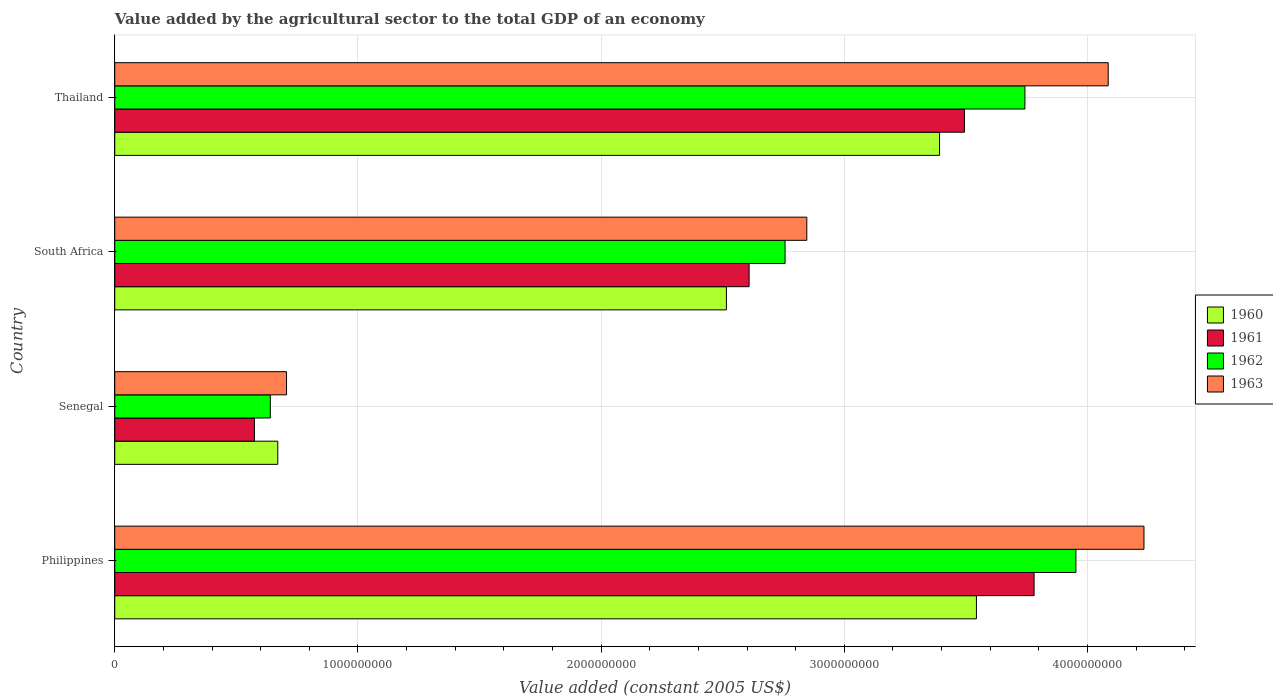How many different coloured bars are there?
Ensure brevity in your answer.  4. Are the number of bars per tick equal to the number of legend labels?
Offer a very short reply. Yes. Are the number of bars on each tick of the Y-axis equal?
Make the answer very short. Yes. How many bars are there on the 3rd tick from the bottom?
Offer a terse response. 4. In how many cases, is the number of bars for a given country not equal to the number of legend labels?
Give a very brief answer. 0. What is the value added by the agricultural sector in 1963 in Philippines?
Your answer should be very brief. 4.23e+09. Across all countries, what is the maximum value added by the agricultural sector in 1962?
Give a very brief answer. 3.95e+09. Across all countries, what is the minimum value added by the agricultural sector in 1963?
Provide a short and direct response. 7.06e+08. In which country was the value added by the agricultural sector in 1960 maximum?
Give a very brief answer. Philippines. In which country was the value added by the agricultural sector in 1963 minimum?
Your response must be concise. Senegal. What is the total value added by the agricultural sector in 1963 in the graph?
Keep it short and to the point. 1.19e+1. What is the difference between the value added by the agricultural sector in 1961 in Senegal and that in Thailand?
Ensure brevity in your answer.  -2.92e+09. What is the difference between the value added by the agricultural sector in 1963 in Thailand and the value added by the agricultural sector in 1961 in South Africa?
Ensure brevity in your answer.  1.48e+09. What is the average value added by the agricultural sector in 1962 per country?
Your answer should be compact. 2.77e+09. What is the difference between the value added by the agricultural sector in 1963 and value added by the agricultural sector in 1961 in Thailand?
Your answer should be very brief. 5.91e+08. In how many countries, is the value added by the agricultural sector in 1962 greater than 600000000 US$?
Your answer should be compact. 4. What is the ratio of the value added by the agricultural sector in 1961 in Philippines to that in Senegal?
Offer a terse response. 6.58. Is the value added by the agricultural sector in 1962 in Philippines less than that in Thailand?
Your answer should be very brief. No. Is the difference between the value added by the agricultural sector in 1963 in Senegal and South Africa greater than the difference between the value added by the agricultural sector in 1961 in Senegal and South Africa?
Provide a short and direct response. No. What is the difference between the highest and the second highest value added by the agricultural sector in 1962?
Offer a very short reply. 2.10e+08. What is the difference between the highest and the lowest value added by the agricultural sector in 1962?
Offer a terse response. 3.31e+09. In how many countries, is the value added by the agricultural sector in 1961 greater than the average value added by the agricultural sector in 1961 taken over all countries?
Your answer should be compact. 2. Is it the case that in every country, the sum of the value added by the agricultural sector in 1961 and value added by the agricultural sector in 1962 is greater than the sum of value added by the agricultural sector in 1960 and value added by the agricultural sector in 1963?
Your response must be concise. No. What does the 3rd bar from the top in South Africa represents?
Provide a succinct answer. 1961. Is it the case that in every country, the sum of the value added by the agricultural sector in 1960 and value added by the agricultural sector in 1961 is greater than the value added by the agricultural sector in 1963?
Offer a terse response. Yes. Are all the bars in the graph horizontal?
Ensure brevity in your answer.  Yes. Does the graph contain grids?
Your answer should be compact. Yes. Where does the legend appear in the graph?
Give a very brief answer. Center right. What is the title of the graph?
Provide a succinct answer. Value added by the agricultural sector to the total GDP of an economy. Does "1995" appear as one of the legend labels in the graph?
Provide a succinct answer. No. What is the label or title of the X-axis?
Your response must be concise. Value added (constant 2005 US$). What is the Value added (constant 2005 US$) in 1960 in Philippines?
Offer a very short reply. 3.54e+09. What is the Value added (constant 2005 US$) in 1961 in Philippines?
Your answer should be compact. 3.78e+09. What is the Value added (constant 2005 US$) in 1962 in Philippines?
Keep it short and to the point. 3.95e+09. What is the Value added (constant 2005 US$) of 1963 in Philippines?
Keep it short and to the point. 4.23e+09. What is the Value added (constant 2005 US$) in 1960 in Senegal?
Make the answer very short. 6.70e+08. What is the Value added (constant 2005 US$) in 1961 in Senegal?
Ensure brevity in your answer.  5.74e+08. What is the Value added (constant 2005 US$) of 1962 in Senegal?
Ensure brevity in your answer.  6.40e+08. What is the Value added (constant 2005 US$) in 1963 in Senegal?
Provide a succinct answer. 7.06e+08. What is the Value added (constant 2005 US$) of 1960 in South Africa?
Give a very brief answer. 2.52e+09. What is the Value added (constant 2005 US$) in 1961 in South Africa?
Your answer should be very brief. 2.61e+09. What is the Value added (constant 2005 US$) in 1962 in South Africa?
Offer a terse response. 2.76e+09. What is the Value added (constant 2005 US$) of 1963 in South Africa?
Offer a very short reply. 2.85e+09. What is the Value added (constant 2005 US$) of 1960 in Thailand?
Make the answer very short. 3.39e+09. What is the Value added (constant 2005 US$) of 1961 in Thailand?
Offer a terse response. 3.49e+09. What is the Value added (constant 2005 US$) of 1962 in Thailand?
Your answer should be compact. 3.74e+09. What is the Value added (constant 2005 US$) of 1963 in Thailand?
Your response must be concise. 4.09e+09. Across all countries, what is the maximum Value added (constant 2005 US$) of 1960?
Offer a terse response. 3.54e+09. Across all countries, what is the maximum Value added (constant 2005 US$) of 1961?
Give a very brief answer. 3.78e+09. Across all countries, what is the maximum Value added (constant 2005 US$) in 1962?
Provide a succinct answer. 3.95e+09. Across all countries, what is the maximum Value added (constant 2005 US$) in 1963?
Your response must be concise. 4.23e+09. Across all countries, what is the minimum Value added (constant 2005 US$) of 1960?
Offer a terse response. 6.70e+08. Across all countries, what is the minimum Value added (constant 2005 US$) in 1961?
Offer a very short reply. 5.74e+08. Across all countries, what is the minimum Value added (constant 2005 US$) of 1962?
Offer a very short reply. 6.40e+08. Across all countries, what is the minimum Value added (constant 2005 US$) of 1963?
Provide a succinct answer. 7.06e+08. What is the total Value added (constant 2005 US$) in 1960 in the graph?
Your response must be concise. 1.01e+1. What is the total Value added (constant 2005 US$) in 1961 in the graph?
Provide a succinct answer. 1.05e+1. What is the total Value added (constant 2005 US$) of 1962 in the graph?
Offer a very short reply. 1.11e+1. What is the total Value added (constant 2005 US$) of 1963 in the graph?
Provide a short and direct response. 1.19e+1. What is the difference between the Value added (constant 2005 US$) of 1960 in Philippines and that in Senegal?
Your response must be concise. 2.87e+09. What is the difference between the Value added (constant 2005 US$) of 1961 in Philippines and that in Senegal?
Ensure brevity in your answer.  3.21e+09. What is the difference between the Value added (constant 2005 US$) of 1962 in Philippines and that in Senegal?
Provide a succinct answer. 3.31e+09. What is the difference between the Value added (constant 2005 US$) of 1963 in Philippines and that in Senegal?
Keep it short and to the point. 3.53e+09. What is the difference between the Value added (constant 2005 US$) of 1960 in Philippines and that in South Africa?
Make the answer very short. 1.03e+09. What is the difference between the Value added (constant 2005 US$) in 1961 in Philippines and that in South Africa?
Offer a terse response. 1.17e+09. What is the difference between the Value added (constant 2005 US$) in 1962 in Philippines and that in South Africa?
Ensure brevity in your answer.  1.20e+09. What is the difference between the Value added (constant 2005 US$) of 1963 in Philippines and that in South Africa?
Your response must be concise. 1.39e+09. What is the difference between the Value added (constant 2005 US$) of 1960 in Philippines and that in Thailand?
Provide a short and direct response. 1.52e+08. What is the difference between the Value added (constant 2005 US$) of 1961 in Philippines and that in Thailand?
Your answer should be very brief. 2.86e+08. What is the difference between the Value added (constant 2005 US$) of 1962 in Philippines and that in Thailand?
Make the answer very short. 2.10e+08. What is the difference between the Value added (constant 2005 US$) of 1963 in Philippines and that in Thailand?
Give a very brief answer. 1.47e+08. What is the difference between the Value added (constant 2005 US$) of 1960 in Senegal and that in South Africa?
Offer a very short reply. -1.84e+09. What is the difference between the Value added (constant 2005 US$) in 1961 in Senegal and that in South Africa?
Your answer should be very brief. -2.03e+09. What is the difference between the Value added (constant 2005 US$) in 1962 in Senegal and that in South Africa?
Offer a terse response. -2.12e+09. What is the difference between the Value added (constant 2005 US$) of 1963 in Senegal and that in South Africa?
Provide a short and direct response. -2.14e+09. What is the difference between the Value added (constant 2005 US$) in 1960 in Senegal and that in Thailand?
Provide a short and direct response. -2.72e+09. What is the difference between the Value added (constant 2005 US$) in 1961 in Senegal and that in Thailand?
Your response must be concise. -2.92e+09. What is the difference between the Value added (constant 2005 US$) in 1962 in Senegal and that in Thailand?
Give a very brief answer. -3.10e+09. What is the difference between the Value added (constant 2005 US$) of 1963 in Senegal and that in Thailand?
Ensure brevity in your answer.  -3.38e+09. What is the difference between the Value added (constant 2005 US$) of 1960 in South Africa and that in Thailand?
Your response must be concise. -8.77e+08. What is the difference between the Value added (constant 2005 US$) in 1961 in South Africa and that in Thailand?
Offer a terse response. -8.86e+08. What is the difference between the Value added (constant 2005 US$) of 1962 in South Africa and that in Thailand?
Provide a succinct answer. -9.86e+08. What is the difference between the Value added (constant 2005 US$) of 1963 in South Africa and that in Thailand?
Provide a succinct answer. -1.24e+09. What is the difference between the Value added (constant 2005 US$) in 1960 in Philippines and the Value added (constant 2005 US$) in 1961 in Senegal?
Your answer should be compact. 2.97e+09. What is the difference between the Value added (constant 2005 US$) of 1960 in Philippines and the Value added (constant 2005 US$) of 1962 in Senegal?
Your answer should be very brief. 2.90e+09. What is the difference between the Value added (constant 2005 US$) in 1960 in Philippines and the Value added (constant 2005 US$) in 1963 in Senegal?
Your response must be concise. 2.84e+09. What is the difference between the Value added (constant 2005 US$) of 1961 in Philippines and the Value added (constant 2005 US$) of 1962 in Senegal?
Offer a very short reply. 3.14e+09. What is the difference between the Value added (constant 2005 US$) of 1961 in Philippines and the Value added (constant 2005 US$) of 1963 in Senegal?
Keep it short and to the point. 3.07e+09. What is the difference between the Value added (constant 2005 US$) of 1962 in Philippines and the Value added (constant 2005 US$) of 1963 in Senegal?
Provide a short and direct response. 3.25e+09. What is the difference between the Value added (constant 2005 US$) of 1960 in Philippines and the Value added (constant 2005 US$) of 1961 in South Africa?
Your response must be concise. 9.35e+08. What is the difference between the Value added (constant 2005 US$) of 1960 in Philippines and the Value added (constant 2005 US$) of 1962 in South Africa?
Provide a succinct answer. 7.87e+08. What is the difference between the Value added (constant 2005 US$) of 1960 in Philippines and the Value added (constant 2005 US$) of 1963 in South Africa?
Provide a short and direct response. 6.98e+08. What is the difference between the Value added (constant 2005 US$) in 1961 in Philippines and the Value added (constant 2005 US$) in 1962 in South Africa?
Provide a short and direct response. 1.02e+09. What is the difference between the Value added (constant 2005 US$) of 1961 in Philippines and the Value added (constant 2005 US$) of 1963 in South Africa?
Make the answer very short. 9.35e+08. What is the difference between the Value added (constant 2005 US$) of 1962 in Philippines and the Value added (constant 2005 US$) of 1963 in South Africa?
Provide a short and direct response. 1.11e+09. What is the difference between the Value added (constant 2005 US$) of 1960 in Philippines and the Value added (constant 2005 US$) of 1961 in Thailand?
Your response must be concise. 4.93e+07. What is the difference between the Value added (constant 2005 US$) in 1960 in Philippines and the Value added (constant 2005 US$) in 1962 in Thailand?
Offer a very short reply. -1.99e+08. What is the difference between the Value added (constant 2005 US$) of 1960 in Philippines and the Value added (constant 2005 US$) of 1963 in Thailand?
Give a very brief answer. -5.42e+08. What is the difference between the Value added (constant 2005 US$) of 1961 in Philippines and the Value added (constant 2005 US$) of 1962 in Thailand?
Offer a terse response. 3.78e+07. What is the difference between the Value added (constant 2005 US$) of 1961 in Philippines and the Value added (constant 2005 US$) of 1963 in Thailand?
Your answer should be very brief. -3.05e+08. What is the difference between the Value added (constant 2005 US$) of 1962 in Philippines and the Value added (constant 2005 US$) of 1963 in Thailand?
Ensure brevity in your answer.  -1.33e+08. What is the difference between the Value added (constant 2005 US$) of 1960 in Senegal and the Value added (constant 2005 US$) of 1961 in South Africa?
Offer a terse response. -1.94e+09. What is the difference between the Value added (constant 2005 US$) of 1960 in Senegal and the Value added (constant 2005 US$) of 1962 in South Africa?
Provide a succinct answer. -2.09e+09. What is the difference between the Value added (constant 2005 US$) of 1960 in Senegal and the Value added (constant 2005 US$) of 1963 in South Africa?
Provide a short and direct response. -2.18e+09. What is the difference between the Value added (constant 2005 US$) in 1961 in Senegal and the Value added (constant 2005 US$) in 1962 in South Africa?
Provide a succinct answer. -2.18e+09. What is the difference between the Value added (constant 2005 US$) in 1961 in Senegal and the Value added (constant 2005 US$) in 1963 in South Africa?
Provide a short and direct response. -2.27e+09. What is the difference between the Value added (constant 2005 US$) of 1962 in Senegal and the Value added (constant 2005 US$) of 1963 in South Africa?
Keep it short and to the point. -2.21e+09. What is the difference between the Value added (constant 2005 US$) in 1960 in Senegal and the Value added (constant 2005 US$) in 1961 in Thailand?
Offer a very short reply. -2.82e+09. What is the difference between the Value added (constant 2005 US$) in 1960 in Senegal and the Value added (constant 2005 US$) in 1962 in Thailand?
Offer a terse response. -3.07e+09. What is the difference between the Value added (constant 2005 US$) in 1960 in Senegal and the Value added (constant 2005 US$) in 1963 in Thailand?
Ensure brevity in your answer.  -3.41e+09. What is the difference between the Value added (constant 2005 US$) in 1961 in Senegal and the Value added (constant 2005 US$) in 1962 in Thailand?
Provide a short and direct response. -3.17e+09. What is the difference between the Value added (constant 2005 US$) in 1961 in Senegal and the Value added (constant 2005 US$) in 1963 in Thailand?
Your answer should be compact. -3.51e+09. What is the difference between the Value added (constant 2005 US$) of 1962 in Senegal and the Value added (constant 2005 US$) of 1963 in Thailand?
Your answer should be very brief. -3.45e+09. What is the difference between the Value added (constant 2005 US$) in 1960 in South Africa and the Value added (constant 2005 US$) in 1961 in Thailand?
Provide a short and direct response. -9.79e+08. What is the difference between the Value added (constant 2005 US$) in 1960 in South Africa and the Value added (constant 2005 US$) in 1962 in Thailand?
Offer a terse response. -1.23e+09. What is the difference between the Value added (constant 2005 US$) of 1960 in South Africa and the Value added (constant 2005 US$) of 1963 in Thailand?
Provide a succinct answer. -1.57e+09. What is the difference between the Value added (constant 2005 US$) of 1961 in South Africa and the Value added (constant 2005 US$) of 1962 in Thailand?
Your response must be concise. -1.13e+09. What is the difference between the Value added (constant 2005 US$) of 1961 in South Africa and the Value added (constant 2005 US$) of 1963 in Thailand?
Your answer should be compact. -1.48e+09. What is the difference between the Value added (constant 2005 US$) in 1962 in South Africa and the Value added (constant 2005 US$) in 1963 in Thailand?
Your response must be concise. -1.33e+09. What is the average Value added (constant 2005 US$) of 1960 per country?
Ensure brevity in your answer.  2.53e+09. What is the average Value added (constant 2005 US$) in 1961 per country?
Your answer should be compact. 2.61e+09. What is the average Value added (constant 2005 US$) in 1962 per country?
Give a very brief answer. 2.77e+09. What is the average Value added (constant 2005 US$) in 1963 per country?
Provide a short and direct response. 2.97e+09. What is the difference between the Value added (constant 2005 US$) in 1960 and Value added (constant 2005 US$) in 1961 in Philippines?
Offer a very short reply. -2.37e+08. What is the difference between the Value added (constant 2005 US$) of 1960 and Value added (constant 2005 US$) of 1962 in Philippines?
Provide a short and direct response. -4.09e+08. What is the difference between the Value added (constant 2005 US$) of 1960 and Value added (constant 2005 US$) of 1963 in Philippines?
Make the answer very short. -6.89e+08. What is the difference between the Value added (constant 2005 US$) of 1961 and Value added (constant 2005 US$) of 1962 in Philippines?
Your response must be concise. -1.72e+08. What is the difference between the Value added (constant 2005 US$) in 1961 and Value added (constant 2005 US$) in 1963 in Philippines?
Offer a very short reply. -4.52e+08. What is the difference between the Value added (constant 2005 US$) of 1962 and Value added (constant 2005 US$) of 1963 in Philippines?
Give a very brief answer. -2.80e+08. What is the difference between the Value added (constant 2005 US$) in 1960 and Value added (constant 2005 US$) in 1961 in Senegal?
Your answer should be compact. 9.60e+07. What is the difference between the Value added (constant 2005 US$) of 1960 and Value added (constant 2005 US$) of 1962 in Senegal?
Ensure brevity in your answer.  3.06e+07. What is the difference between the Value added (constant 2005 US$) of 1960 and Value added (constant 2005 US$) of 1963 in Senegal?
Offer a terse response. -3.60e+07. What is the difference between the Value added (constant 2005 US$) of 1961 and Value added (constant 2005 US$) of 1962 in Senegal?
Offer a terse response. -6.53e+07. What is the difference between the Value added (constant 2005 US$) in 1961 and Value added (constant 2005 US$) in 1963 in Senegal?
Make the answer very short. -1.32e+08. What is the difference between the Value added (constant 2005 US$) in 1962 and Value added (constant 2005 US$) in 1963 in Senegal?
Offer a terse response. -6.67e+07. What is the difference between the Value added (constant 2005 US$) in 1960 and Value added (constant 2005 US$) in 1961 in South Africa?
Keep it short and to the point. -9.34e+07. What is the difference between the Value added (constant 2005 US$) of 1960 and Value added (constant 2005 US$) of 1962 in South Africa?
Keep it short and to the point. -2.41e+08. What is the difference between the Value added (constant 2005 US$) of 1960 and Value added (constant 2005 US$) of 1963 in South Africa?
Provide a succinct answer. -3.31e+08. What is the difference between the Value added (constant 2005 US$) of 1961 and Value added (constant 2005 US$) of 1962 in South Africa?
Offer a very short reply. -1.48e+08. What is the difference between the Value added (constant 2005 US$) in 1961 and Value added (constant 2005 US$) in 1963 in South Africa?
Make the answer very short. -2.37e+08. What is the difference between the Value added (constant 2005 US$) of 1962 and Value added (constant 2005 US$) of 1963 in South Africa?
Make the answer very short. -8.93e+07. What is the difference between the Value added (constant 2005 US$) in 1960 and Value added (constant 2005 US$) in 1961 in Thailand?
Your response must be concise. -1.02e+08. What is the difference between the Value added (constant 2005 US$) of 1960 and Value added (constant 2005 US$) of 1962 in Thailand?
Your answer should be very brief. -3.51e+08. What is the difference between the Value added (constant 2005 US$) in 1960 and Value added (constant 2005 US$) in 1963 in Thailand?
Your response must be concise. -6.94e+08. What is the difference between the Value added (constant 2005 US$) of 1961 and Value added (constant 2005 US$) of 1962 in Thailand?
Your answer should be very brief. -2.49e+08. What is the difference between the Value added (constant 2005 US$) in 1961 and Value added (constant 2005 US$) in 1963 in Thailand?
Your response must be concise. -5.91e+08. What is the difference between the Value added (constant 2005 US$) of 1962 and Value added (constant 2005 US$) of 1963 in Thailand?
Make the answer very short. -3.43e+08. What is the ratio of the Value added (constant 2005 US$) in 1960 in Philippines to that in Senegal?
Ensure brevity in your answer.  5.29. What is the ratio of the Value added (constant 2005 US$) in 1961 in Philippines to that in Senegal?
Make the answer very short. 6.58. What is the ratio of the Value added (constant 2005 US$) in 1962 in Philippines to that in Senegal?
Keep it short and to the point. 6.18. What is the ratio of the Value added (constant 2005 US$) in 1963 in Philippines to that in Senegal?
Keep it short and to the point. 5.99. What is the ratio of the Value added (constant 2005 US$) in 1960 in Philippines to that in South Africa?
Provide a short and direct response. 1.41. What is the ratio of the Value added (constant 2005 US$) in 1961 in Philippines to that in South Africa?
Your answer should be very brief. 1.45. What is the ratio of the Value added (constant 2005 US$) of 1962 in Philippines to that in South Africa?
Your answer should be compact. 1.43. What is the ratio of the Value added (constant 2005 US$) in 1963 in Philippines to that in South Africa?
Offer a terse response. 1.49. What is the ratio of the Value added (constant 2005 US$) of 1960 in Philippines to that in Thailand?
Provide a short and direct response. 1.04. What is the ratio of the Value added (constant 2005 US$) of 1961 in Philippines to that in Thailand?
Provide a succinct answer. 1.08. What is the ratio of the Value added (constant 2005 US$) of 1962 in Philippines to that in Thailand?
Give a very brief answer. 1.06. What is the ratio of the Value added (constant 2005 US$) of 1963 in Philippines to that in Thailand?
Provide a succinct answer. 1.04. What is the ratio of the Value added (constant 2005 US$) of 1960 in Senegal to that in South Africa?
Offer a very short reply. 0.27. What is the ratio of the Value added (constant 2005 US$) in 1961 in Senegal to that in South Africa?
Give a very brief answer. 0.22. What is the ratio of the Value added (constant 2005 US$) of 1962 in Senegal to that in South Africa?
Keep it short and to the point. 0.23. What is the ratio of the Value added (constant 2005 US$) of 1963 in Senegal to that in South Africa?
Your answer should be very brief. 0.25. What is the ratio of the Value added (constant 2005 US$) in 1960 in Senegal to that in Thailand?
Keep it short and to the point. 0.2. What is the ratio of the Value added (constant 2005 US$) of 1961 in Senegal to that in Thailand?
Your response must be concise. 0.16. What is the ratio of the Value added (constant 2005 US$) of 1962 in Senegal to that in Thailand?
Make the answer very short. 0.17. What is the ratio of the Value added (constant 2005 US$) in 1963 in Senegal to that in Thailand?
Your answer should be very brief. 0.17. What is the ratio of the Value added (constant 2005 US$) in 1960 in South Africa to that in Thailand?
Your answer should be very brief. 0.74. What is the ratio of the Value added (constant 2005 US$) in 1961 in South Africa to that in Thailand?
Offer a terse response. 0.75. What is the ratio of the Value added (constant 2005 US$) of 1962 in South Africa to that in Thailand?
Your answer should be compact. 0.74. What is the ratio of the Value added (constant 2005 US$) of 1963 in South Africa to that in Thailand?
Your answer should be compact. 0.7. What is the difference between the highest and the second highest Value added (constant 2005 US$) in 1960?
Offer a very short reply. 1.52e+08. What is the difference between the highest and the second highest Value added (constant 2005 US$) in 1961?
Your response must be concise. 2.86e+08. What is the difference between the highest and the second highest Value added (constant 2005 US$) of 1962?
Offer a very short reply. 2.10e+08. What is the difference between the highest and the second highest Value added (constant 2005 US$) in 1963?
Provide a short and direct response. 1.47e+08. What is the difference between the highest and the lowest Value added (constant 2005 US$) in 1960?
Your response must be concise. 2.87e+09. What is the difference between the highest and the lowest Value added (constant 2005 US$) in 1961?
Your answer should be compact. 3.21e+09. What is the difference between the highest and the lowest Value added (constant 2005 US$) in 1962?
Your response must be concise. 3.31e+09. What is the difference between the highest and the lowest Value added (constant 2005 US$) in 1963?
Your answer should be compact. 3.53e+09. 